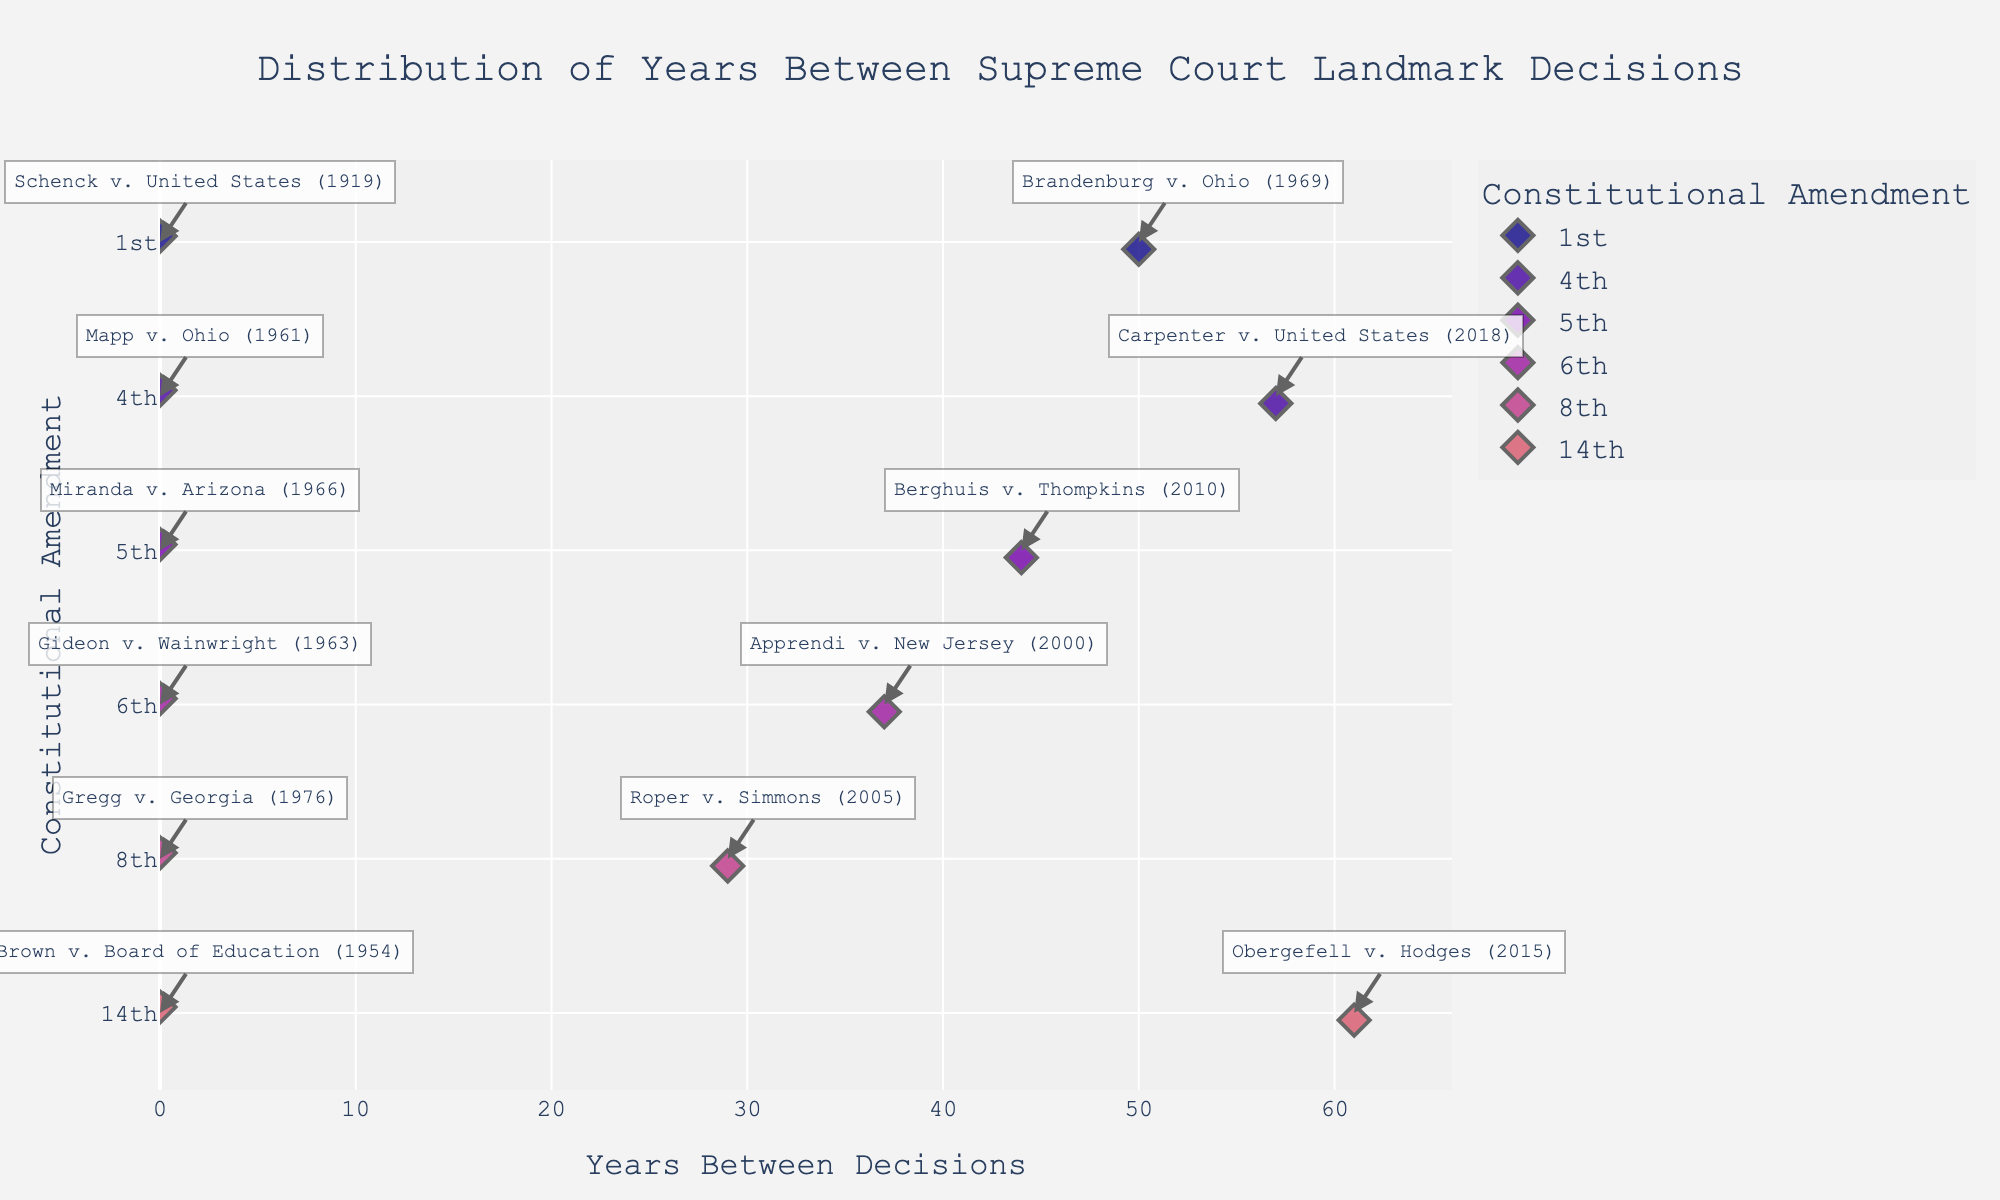What's the title of the figure? The title of the figure is typically prominently displayed at the top. Here, it is "Distribution of Years Between Supreme Court Landmark Decisions".
Answer: Distribution of Years Between Supreme Court Landmark Decisions How is the 'Years Between Decisions' represented in the plot? 'Years Between Decisions' is represented on the x-axis of the plot. This axis shows the number of years between landmark decisions per constitutional amendment.
Answer: On the x-axis What is the color scheme used in the plot? The figure uses a color scheme from the Plasma sequential color scale, which ranges from dark to bright colors.
Answer: Plasma color scale How many landmark cases are represented for the 1st Amendment? By looking at the number of data points for the 1st Amendment on the y-axis, we count the distinct markers. There are 2 cases for the 1st Amendment.
Answer: 2 What is the shortest duration between landmark decisions for any amendment? The shortest duration between decisions can be seen by looking at the x-axis values and the respective annotations on the plot. The minimum value is 0 years, as seen in the plot (or more specifically from the 14th Amendment).
Answer: 0 years Which amendment has the widest range of years between decisions? The amendment with the widest range will have points spread out the most on the x-axis. By comparing the spread, the 14th Amendment has a considerably wide range from 0 to 61 years.
Answer: 14th Amendment What's the average duration between landmark decisions for the 5th Amendment? To find the average, sum up the years between the two decisions for the 5th Amendment and divide by the number of intervals. The two decisions are 1966 and 2010, which is a 44-year gap. Since there’s only one interval, the average is 44 years.
Answer: 44 years For which amendments do the landmark decisions span more than 50 years? By looking at the annotations and the spread on the x-axis, the 1st and 14th Amendments span more than 50 years. For example, the 1st Amendment decisions range from 1919 to 1969 (50 years), and the 14th Amendment from 1954 to 2015 (61 years).
Answer: 1st and 14th Amendments Which amendment has the most homogeneous distribution of years between decisions? The most homogeneous distribution means the years between decisions are closest in range. The 8th Amendment has relatively even intervals between its two landmark decisions (1976 and 2005), approximately 29 years apart consistently.
Answer: 8th Amendment 